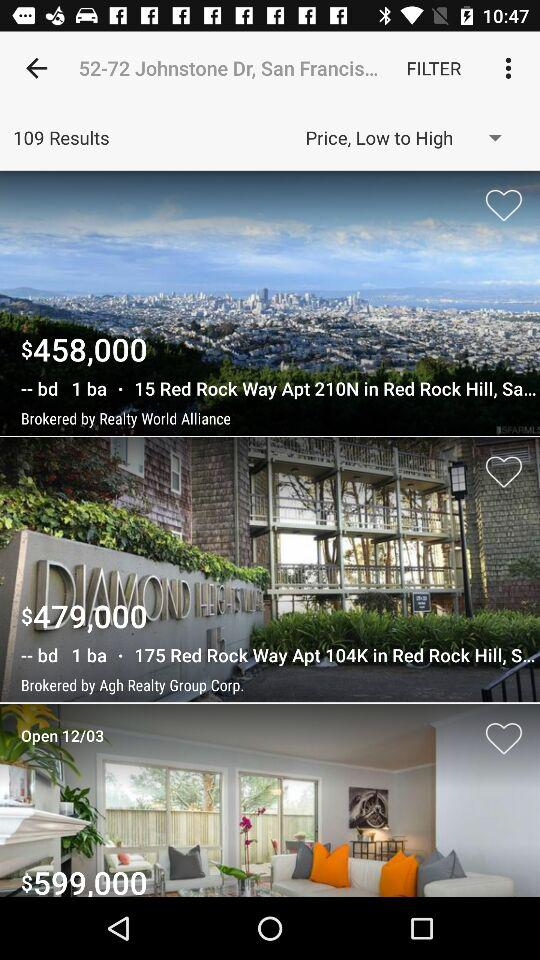How many results are shown? There are 109 results shown. 